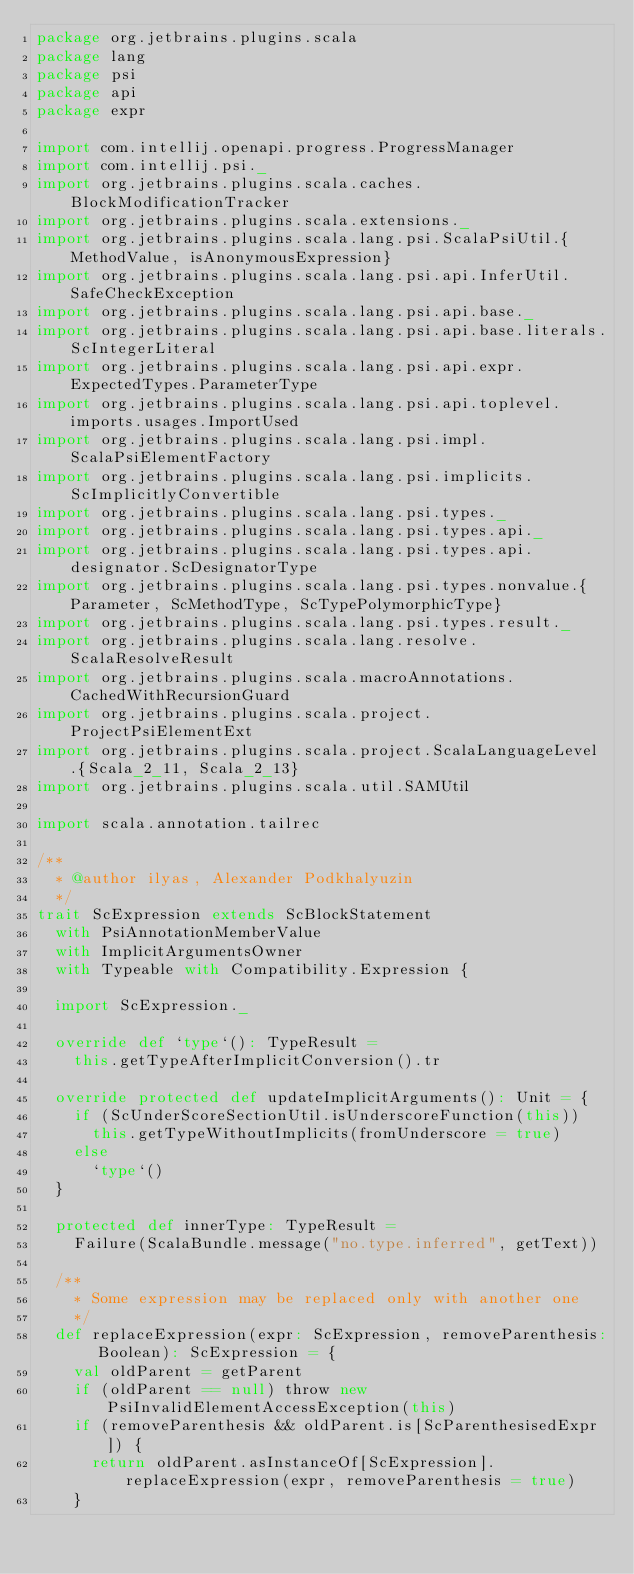<code> <loc_0><loc_0><loc_500><loc_500><_Scala_>package org.jetbrains.plugins.scala
package lang
package psi
package api
package expr

import com.intellij.openapi.progress.ProgressManager
import com.intellij.psi._
import org.jetbrains.plugins.scala.caches.BlockModificationTracker
import org.jetbrains.plugins.scala.extensions._
import org.jetbrains.plugins.scala.lang.psi.ScalaPsiUtil.{MethodValue, isAnonymousExpression}
import org.jetbrains.plugins.scala.lang.psi.api.InferUtil.SafeCheckException
import org.jetbrains.plugins.scala.lang.psi.api.base._
import org.jetbrains.plugins.scala.lang.psi.api.base.literals.ScIntegerLiteral
import org.jetbrains.plugins.scala.lang.psi.api.expr.ExpectedTypes.ParameterType
import org.jetbrains.plugins.scala.lang.psi.api.toplevel.imports.usages.ImportUsed
import org.jetbrains.plugins.scala.lang.psi.impl.ScalaPsiElementFactory
import org.jetbrains.plugins.scala.lang.psi.implicits.ScImplicitlyConvertible
import org.jetbrains.plugins.scala.lang.psi.types._
import org.jetbrains.plugins.scala.lang.psi.types.api._
import org.jetbrains.plugins.scala.lang.psi.types.api.designator.ScDesignatorType
import org.jetbrains.plugins.scala.lang.psi.types.nonvalue.{Parameter, ScMethodType, ScTypePolymorphicType}
import org.jetbrains.plugins.scala.lang.psi.types.result._
import org.jetbrains.plugins.scala.lang.resolve.ScalaResolveResult
import org.jetbrains.plugins.scala.macroAnnotations.CachedWithRecursionGuard
import org.jetbrains.plugins.scala.project.ProjectPsiElementExt
import org.jetbrains.plugins.scala.project.ScalaLanguageLevel.{Scala_2_11, Scala_2_13}
import org.jetbrains.plugins.scala.util.SAMUtil

import scala.annotation.tailrec

/**
  * @author ilyas, Alexander Podkhalyuzin
  */
trait ScExpression extends ScBlockStatement
  with PsiAnnotationMemberValue
  with ImplicitArgumentsOwner
  with Typeable with Compatibility.Expression {

  import ScExpression._

  override def `type`(): TypeResult =
    this.getTypeAfterImplicitConversion().tr

  override protected def updateImplicitArguments(): Unit = {
    if (ScUnderScoreSectionUtil.isUnderscoreFunction(this))
      this.getTypeWithoutImplicits(fromUnderscore = true)
    else
      `type`()
  }

  protected def innerType: TypeResult =
    Failure(ScalaBundle.message("no.type.inferred", getText))

  /**
    * Some expression may be replaced only with another one
    */
  def replaceExpression(expr: ScExpression, removeParenthesis: Boolean): ScExpression = {
    val oldParent = getParent
    if (oldParent == null) throw new PsiInvalidElementAccessException(this)
    if (removeParenthesis && oldParent.is[ScParenthesisedExpr]) {
      return oldParent.asInstanceOf[ScExpression].replaceExpression(expr, removeParenthesis = true)
    }</code> 